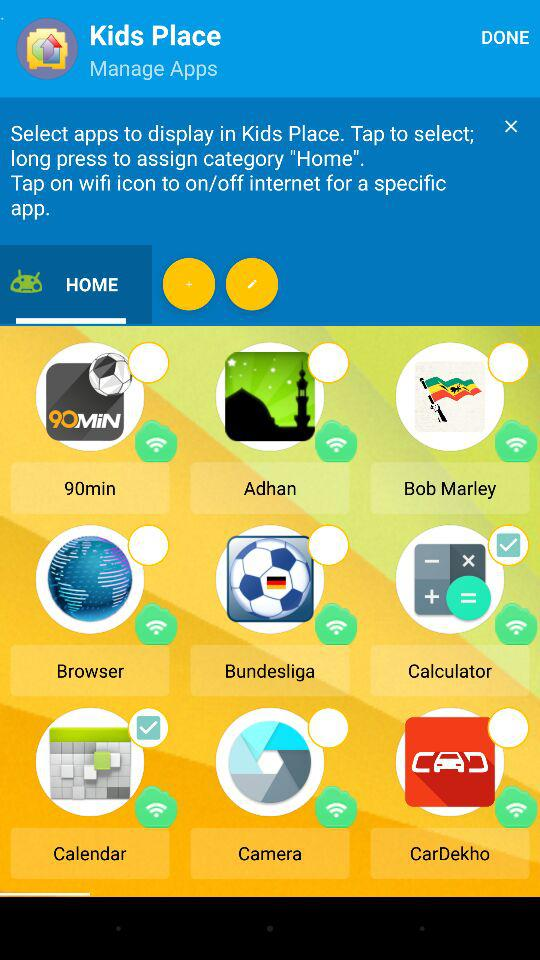What is the name of the category? The name of the category is "HOME". 